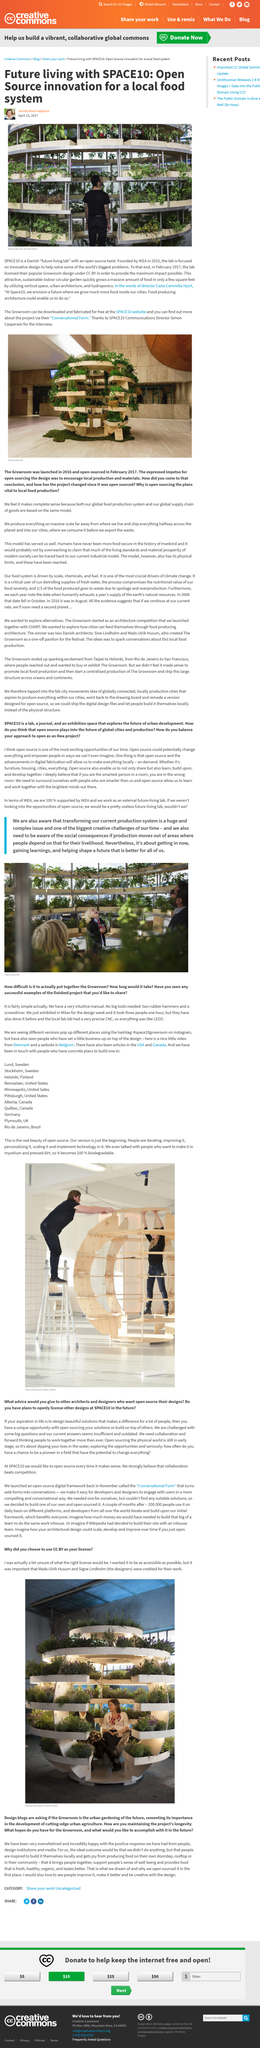Highlight a few significant elements in this photo. It is crucial for individuals to be aware of the social consequences that may result from their actions. The future living lab founded by IKEA is focused on local food systems, not global ones. The Growroom design was licensed by the lab in February 2017. In 2015, IKEA established SPACE10, a research and collaboration platform focused on exploring sustainable design and future of living. Transforming our current production system is described as a massive and daunting task. 